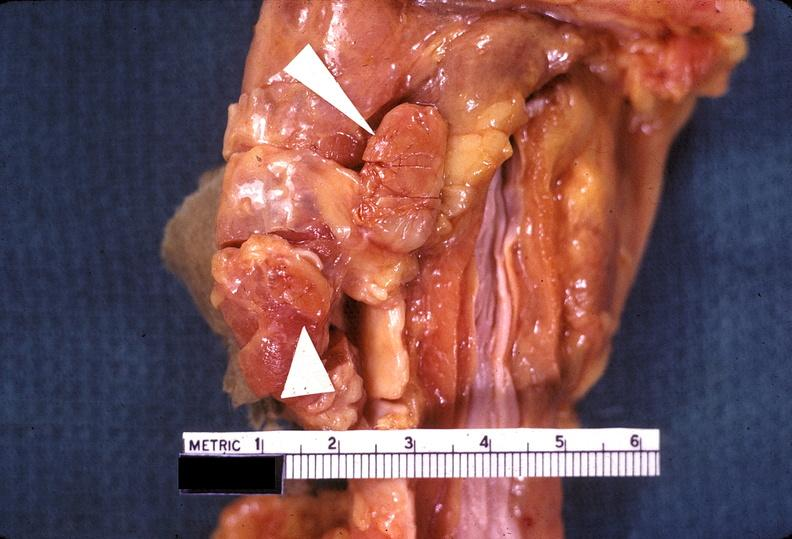s endocrine present?
Answer the question using a single word or phrase. Yes 